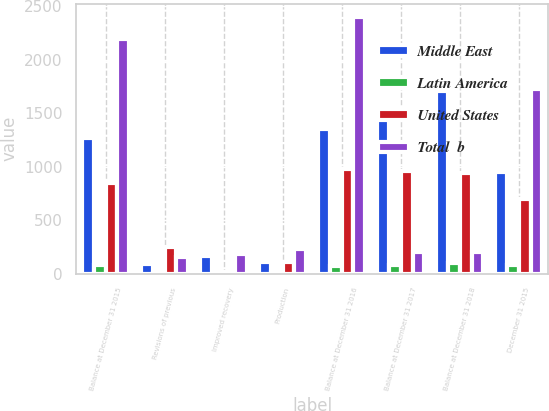Convert chart. <chart><loc_0><loc_0><loc_500><loc_500><stacked_bar_chart><ecel><fcel>Balance at December 31 2015<fcel>Revisions of previous<fcel>Improved recovery<fcel>Production<fcel>Balance at December 31 2016<fcel>Balance at December 31 2017<fcel>Balance at December 31 2018<fcel>December 31 2015<nl><fcel>Middle East<fcel>1271<fcel>92<fcel>165<fcel>110<fcel>1353<fcel>1555<fcel>1711<fcel>950<nl><fcel>Latin America<fcel>80<fcel>3<fcel>2<fcel>13<fcel>72<fcel>84<fcel>98<fcel>80<nl><fcel>United States<fcel>849<fcel>248<fcel>18<fcel>108<fcel>981<fcel>959<fcel>943<fcel>702<nl><fcel>Total  b<fcel>2200<fcel>159<fcel>185<fcel>231<fcel>2406<fcel>208<fcel>208<fcel>1732<nl></chart> 